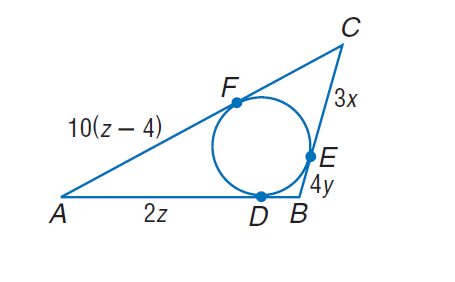Question: Find the perimeter of the polygon for the given information. C F = 6(3 - x), D B = 12 y - 4.
Choices:
A. 36
B. 72
C. 90
D. 108
Answer with the letter. Answer: A 